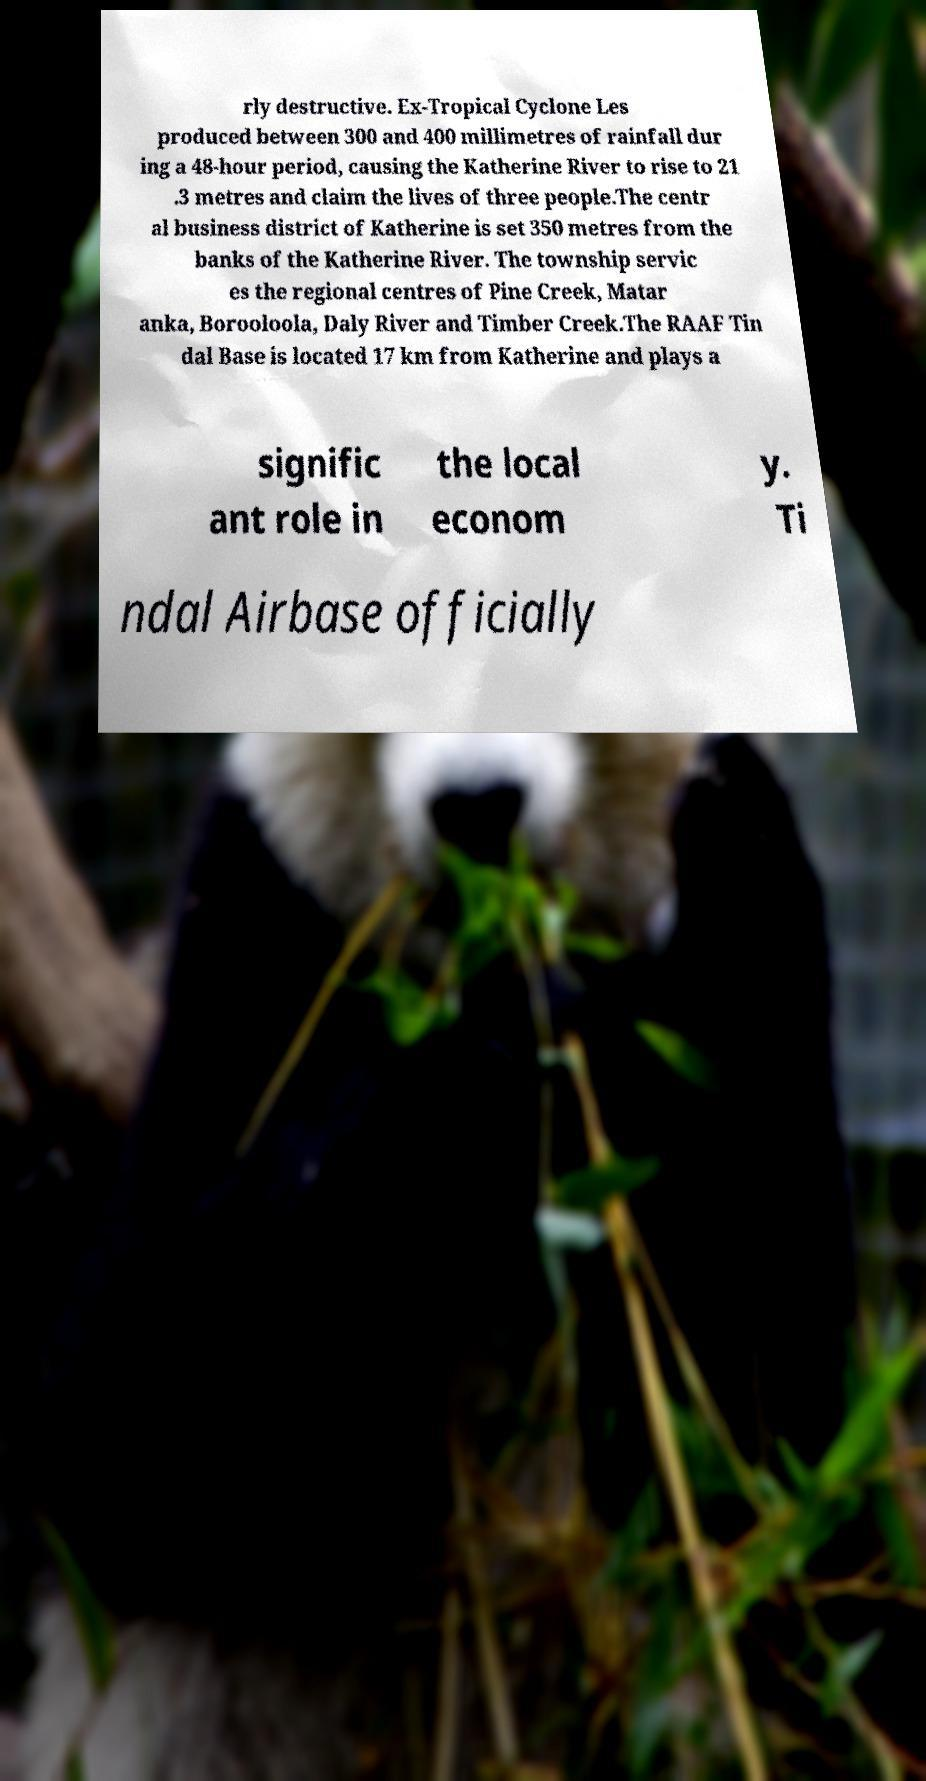Please read and relay the text visible in this image. What does it say? rly destructive. Ex-Tropical Cyclone Les produced between 300 and 400 millimetres of rainfall dur ing a 48-hour period, causing the Katherine River to rise to 21 .3 metres and claim the lives of three people.The centr al business district of Katherine is set 350 metres from the banks of the Katherine River. The township servic es the regional centres of Pine Creek, Matar anka, Borooloola, Daly River and Timber Creek.The RAAF Tin dal Base is located 17 km from Katherine and plays a signific ant role in the local econom y. Ti ndal Airbase officially 